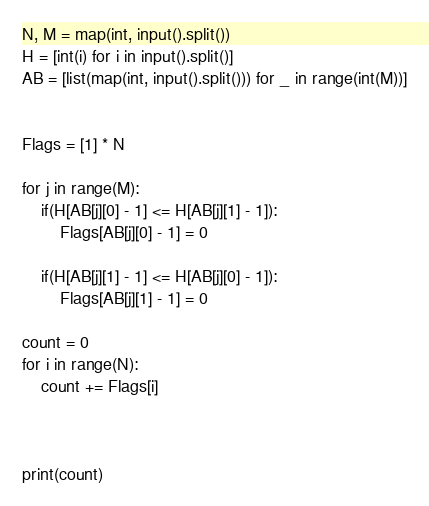Convert code to text. <code><loc_0><loc_0><loc_500><loc_500><_Python_>N, M = map(int, input().split())
H = [int(i) for i in input().split()]
AB = [list(map(int, input().split())) for _ in range(int(M))]


Flags = [1] * N

for j in range(M):
    if(H[AB[j][0] - 1] <= H[AB[j][1] - 1]):
        Flags[AB[j][0] - 1] = 0

    if(H[AB[j][1] - 1] <= H[AB[j][0] - 1]):
        Flags[AB[j][1] - 1] = 0

count = 0
for i in range(N):
    count += Flags[i]



print(count)
</code> 